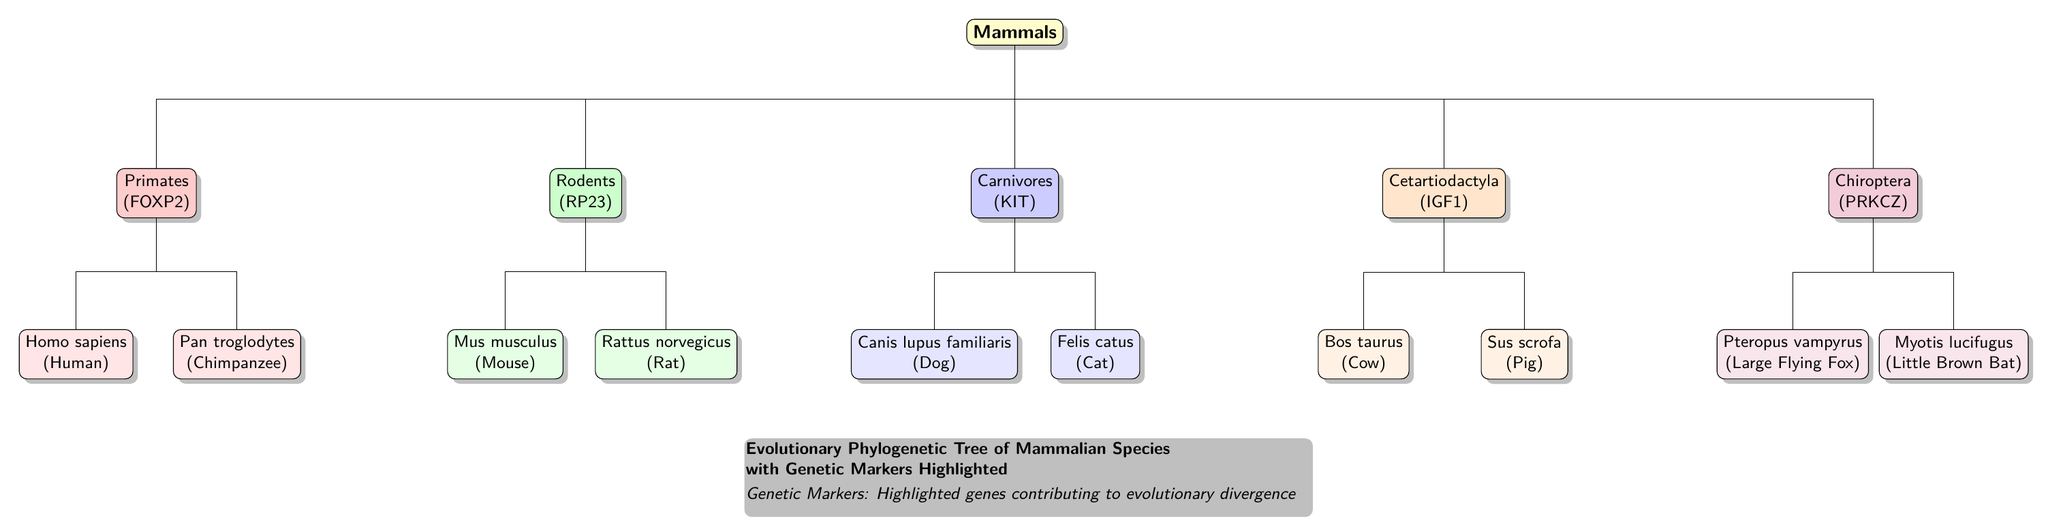What is the genetic marker for Primates? The diagram shows that the genetic marker for Primates is FOXP2, which is listed next to the Primates node.
Answer: FOXP2 How many major groups of mammals are shown in the diagram? By counting the main branches from the Mammals node, there are five distinct groups represented: Primates, Rodents, Carnivores, Cetartiodactyla, and Chiroptera.
Answer: 5 Which mammalian species is represented under the Rodents category? The diagram displays Mus musculus (Mouse) and Rattus norvegicus (Rat) as the species under the Rodents category. Since the question asks for one species, we can choose either.
Answer: Mus musculus What is the genetic marker for the Carnivores group? According to the diagram, the genetic marker associated with the Carnivores group is KIT, as indicated next to the Carnivores node.
Answer: KIT Which species is closest to Homo sapiens on the evolutionary tree? Following the tree structure, Pan troglodytes (Chimpanzee) is placed directly below Homo sapiens, indicating that it is the closest relative in this diagram.
Answer: Pan troglodytes What color is used to represent the Chiroptera category? The Chiroptera category is highlighted with a purple color in the diagram, which is evident from the fill color of the respective node.
Answer: Purple Which species is depicted as part of the Cetartiodactyla category? The diagram indicates that Bos taurus (Cow) and Sus scrofa (Pig) are included under the Cetartiodactyla category, so either can be the answer depending on preference.
Answer: Bos taurus What type of marker is highlighted for the Cetartiodactyla group? The diagram specifies IGF1 as the genetic marker for the Cetartiodactyla group next to the respective node's label.
Answer: IGF1 Which mammalian group has the genetic marker PRKCZ? The diagram indicates that PRKCZ is the genetic marker for the Chiroptera group, which is specifically labeled next to the Chiroptera node.
Answer: Chiroptera 